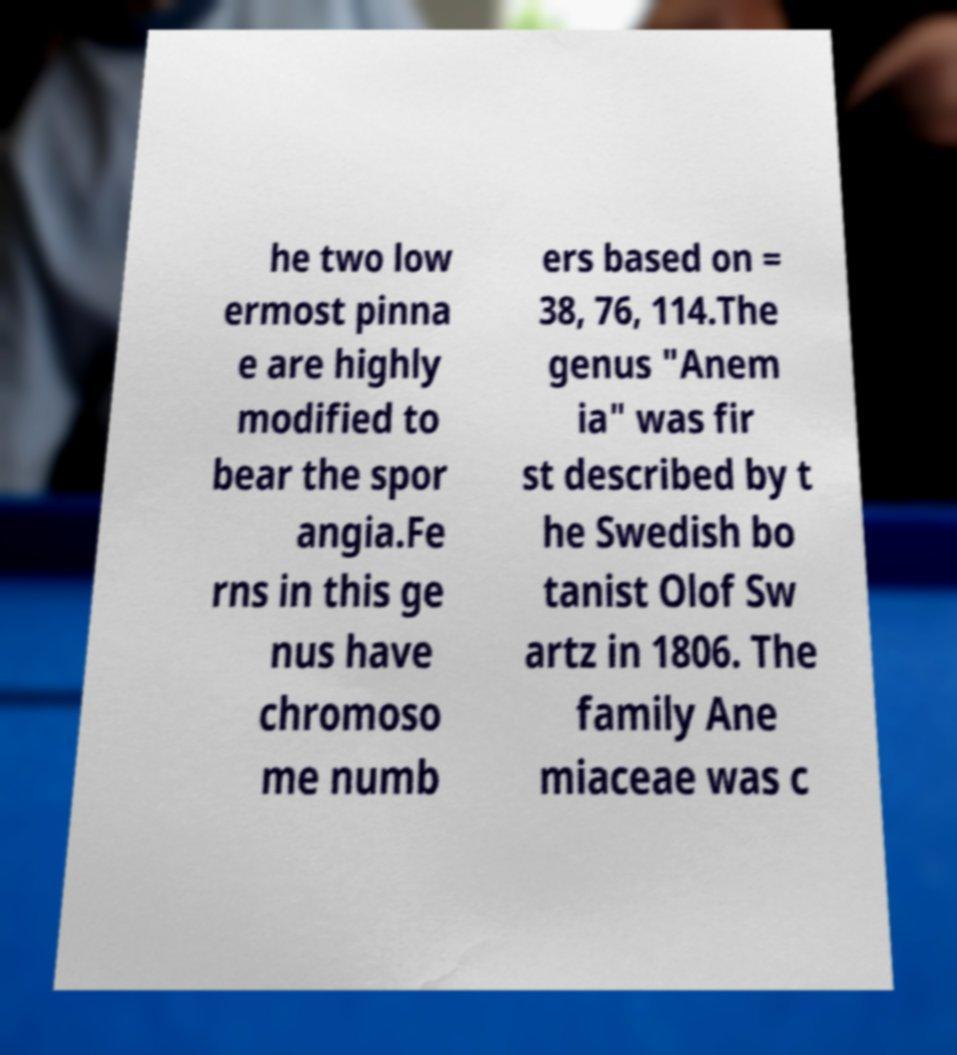What messages or text are displayed in this image? I need them in a readable, typed format. he two low ermost pinna e are highly modified to bear the spor angia.Fe rns in this ge nus have chromoso me numb ers based on = 38, 76, 114.The genus "Anem ia" was fir st described by t he Swedish bo tanist Olof Sw artz in 1806. The family Ane miaceae was c 